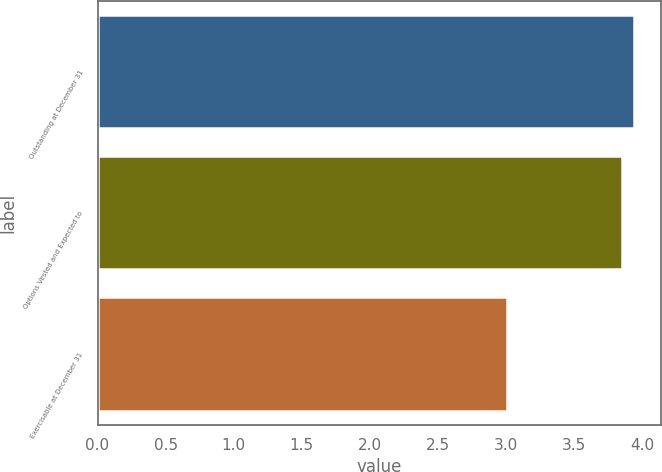Convert chart to OTSL. <chart><loc_0><loc_0><loc_500><loc_500><bar_chart><fcel>Outstanding at December 31<fcel>Options Vested and Expected to<fcel>Exercisable at December 31<nl><fcel>3.94<fcel>3.85<fcel>3.01<nl></chart> 